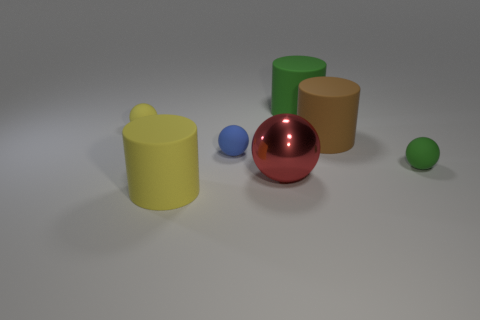Add 3 brown metal blocks. How many objects exist? 10 Subtract all cylinders. How many objects are left? 4 Add 7 blue spheres. How many blue spheres are left? 8 Add 3 rubber things. How many rubber things exist? 9 Subtract 1 green cylinders. How many objects are left? 6 Subtract all yellow matte spheres. Subtract all green rubber balls. How many objects are left? 5 